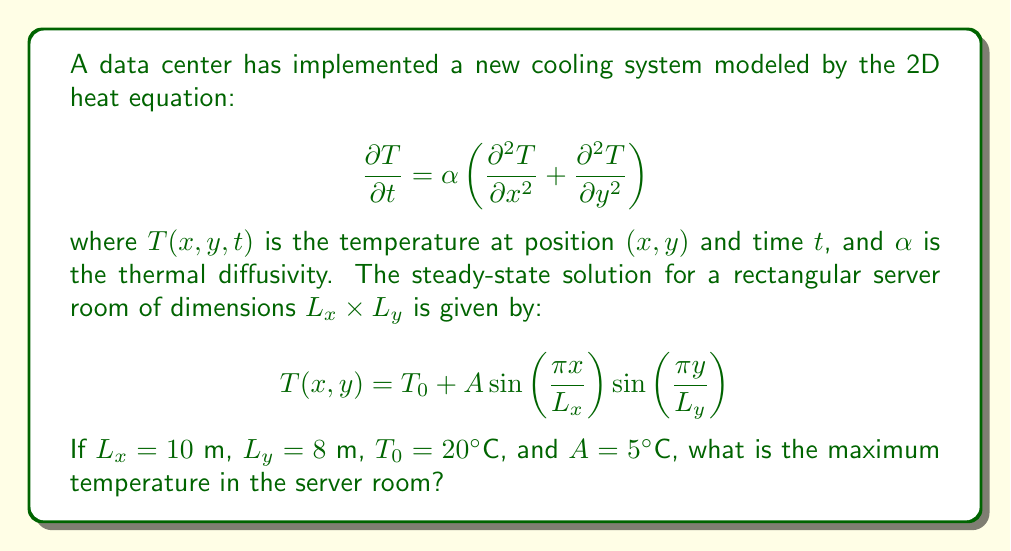Could you help me with this problem? To find the maximum temperature in the server room, we need to follow these steps:

1) The given steady-state solution is:
   $$T(x,y) = T_0 + A \sin\left(\frac{\pi x}{L_x}\right) \sin\left(\frac{\pi y}{L_y}\right)$$

2) We're given:
   $T_0 = 20°C$ (base temperature)
   $A = 5°C$ (amplitude)
   $L_x = 10$ m
   $L_y = 8$ m

3) The maximum temperature will occur when both sine terms reach their maximum value of 1. This happens when:
   $$\sin\left(\frac{\pi x}{L_x}\right) = 1$$ and $$\sin\left(\frac{\pi y}{L_y}\right) = 1$$

4) The sine function reaches its maximum value of 1 when its argument is $\frac{\pi}{2}$ (or odd multiples of it). So, the maximum occurs at:
   $$\frac{\pi x}{L_x} = \frac{\pi}{2}$$ and $$\frac{\pi y}{L_y} = \frac{\pi}{2}$$

5) We don't need to solve for $x$ and $y$ explicitly, as we're only interested in the maximum temperature.

6) At this maximum point, the temperature will be:
   $$T_{max} = T_0 + A(1)(1) = 20°C + 5°C = 25°C$$

Therefore, the maximum temperature in the server room is 25°C.
Answer: 25°C 